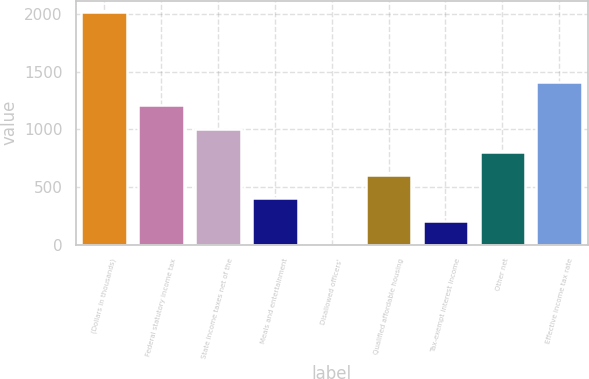<chart> <loc_0><loc_0><loc_500><loc_500><bar_chart><fcel>(Dollars in thousands)<fcel>Federal statutory income tax<fcel>State income taxes net of the<fcel>Meals and entertainment<fcel>Disallowed officers'<fcel>Qualified affordable housing<fcel>Tax-exempt interest income<fcel>Other net<fcel>Effective income tax rate<nl><fcel>2016<fcel>1209.64<fcel>1008.05<fcel>403.28<fcel>0.1<fcel>604.87<fcel>201.69<fcel>806.46<fcel>1411.23<nl></chart> 